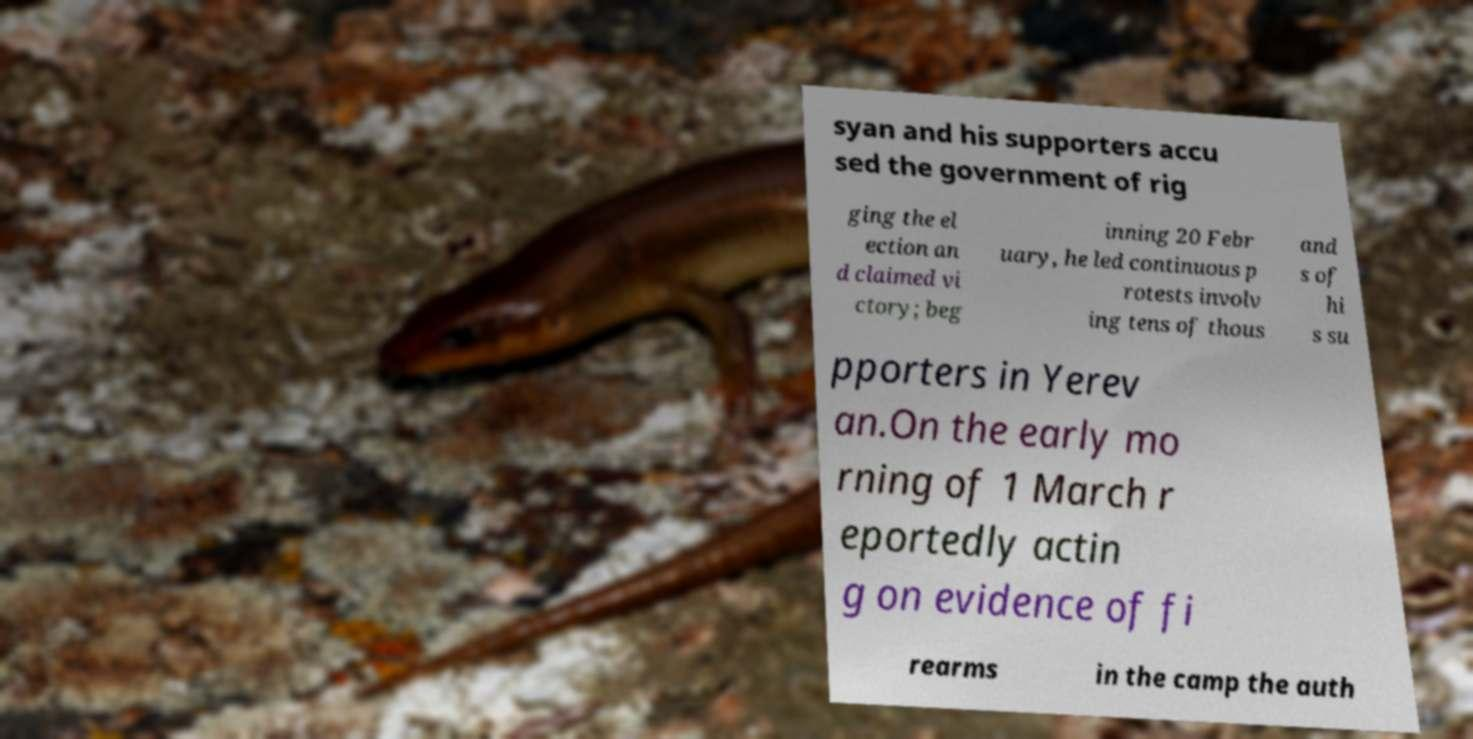Could you extract and type out the text from this image? syan and his supporters accu sed the government of rig ging the el ection an d claimed vi ctory; beg inning 20 Febr uary, he led continuous p rotests involv ing tens of thous and s of hi s su pporters in Yerev an.On the early mo rning of 1 March r eportedly actin g on evidence of fi rearms in the camp the auth 